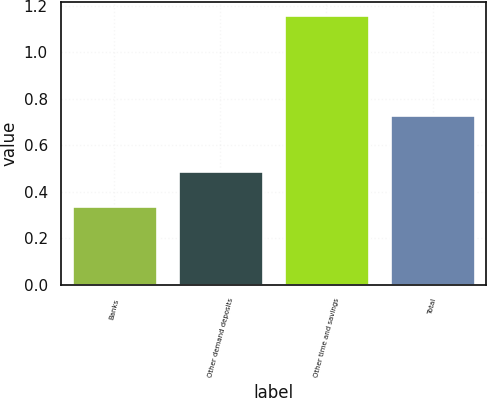Convert chart to OTSL. <chart><loc_0><loc_0><loc_500><loc_500><bar_chart><fcel>Banks<fcel>Other demand deposits<fcel>Other time and savings<fcel>Total<nl><fcel>0.34<fcel>0.49<fcel>1.16<fcel>0.73<nl></chart> 